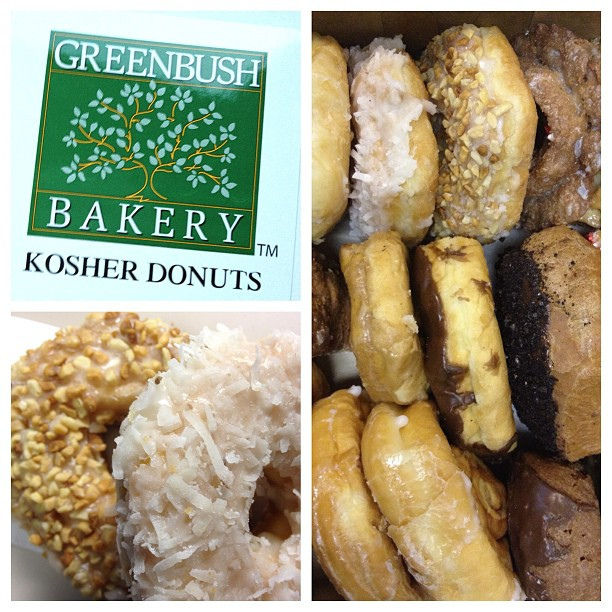Identify the text displayed in this image. GREENBUSH BAKERY KOSHER DONUTS TM 